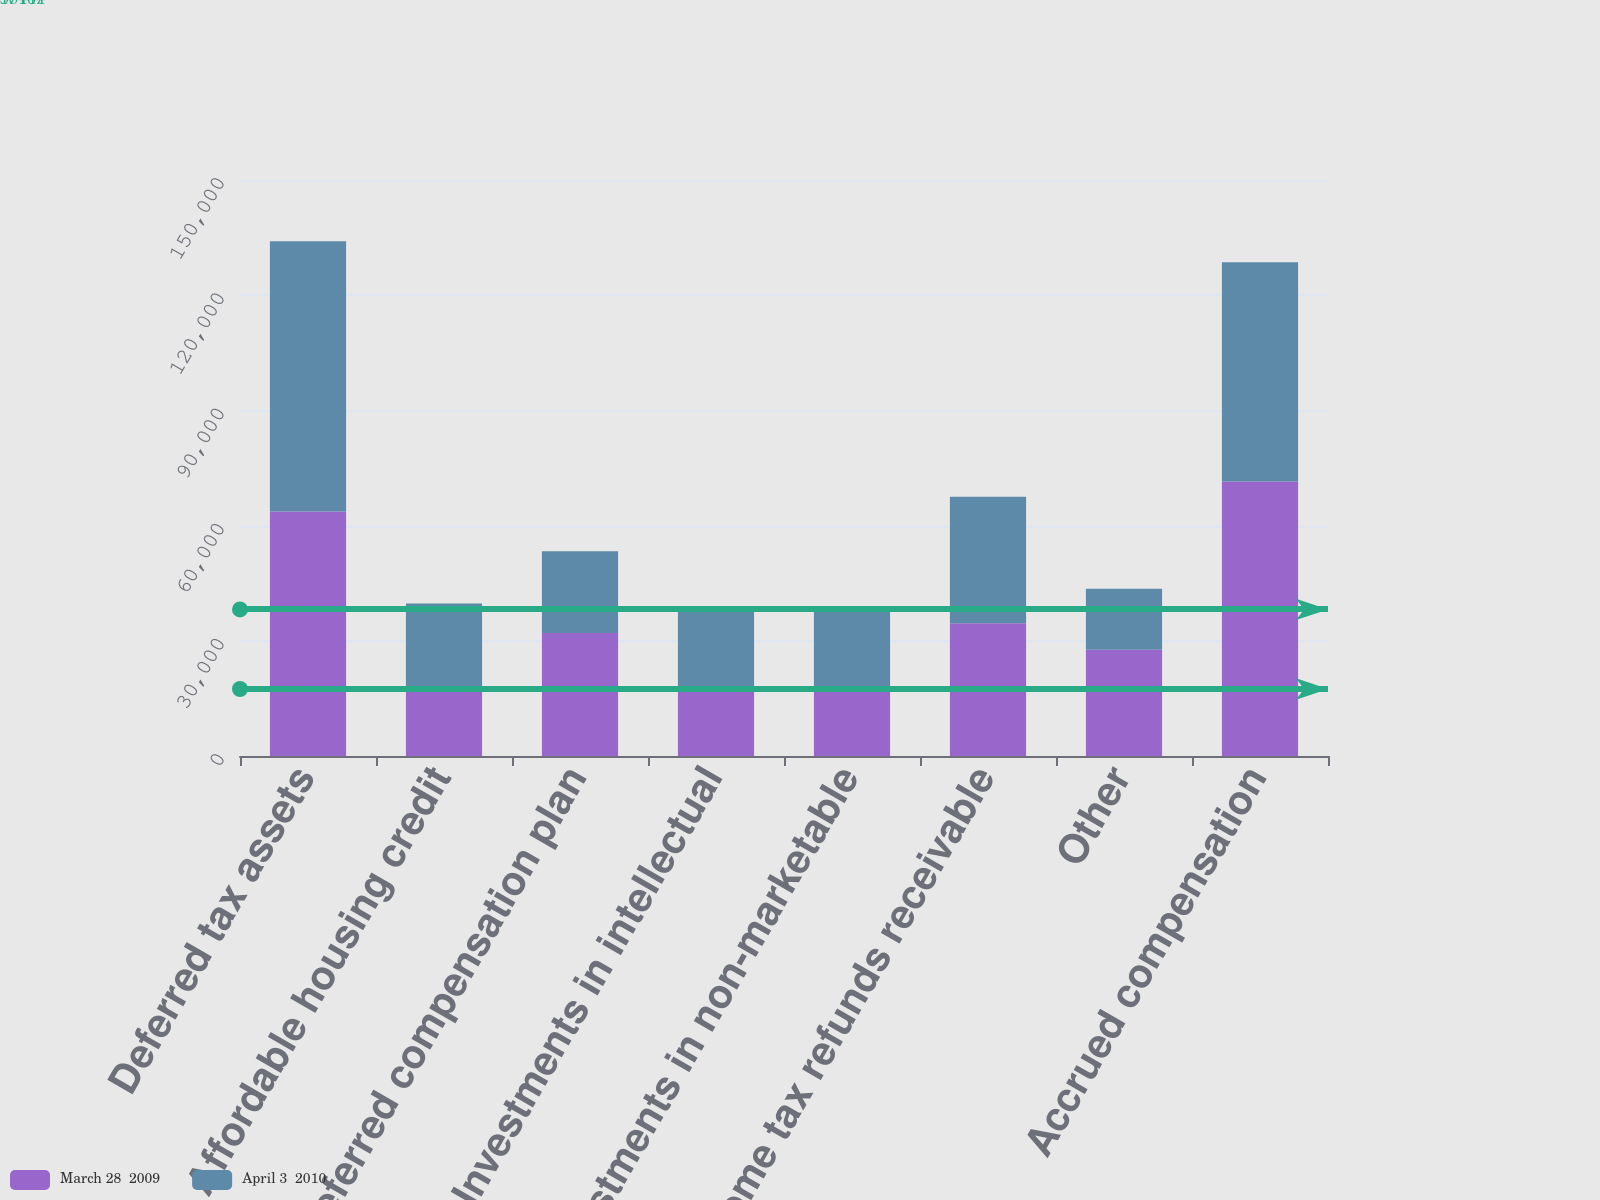<chart> <loc_0><loc_0><loc_500><loc_500><stacked_bar_chart><ecel><fcel>Deferred tax assets<fcel>Affordable housing credit<fcel>Deferred compensation plan<fcel>Investments in intellectual<fcel>Investments in non-marketable<fcel>Income tax refunds receivable<fcel>Other<fcel>Accrued compensation<nl><fcel>March 28  2009<fcel>63691<fcel>17447<fcel>32046<fcel>18130<fcel>17679<fcel>34542<fcel>27682<fcel>71505<nl><fcel>April 3  2010<fcel>70373<fcel>22245<fcel>21283<fcel>20034<fcel>20519<fcel>32953<fcel>15884<fcel>57053<nl></chart> 